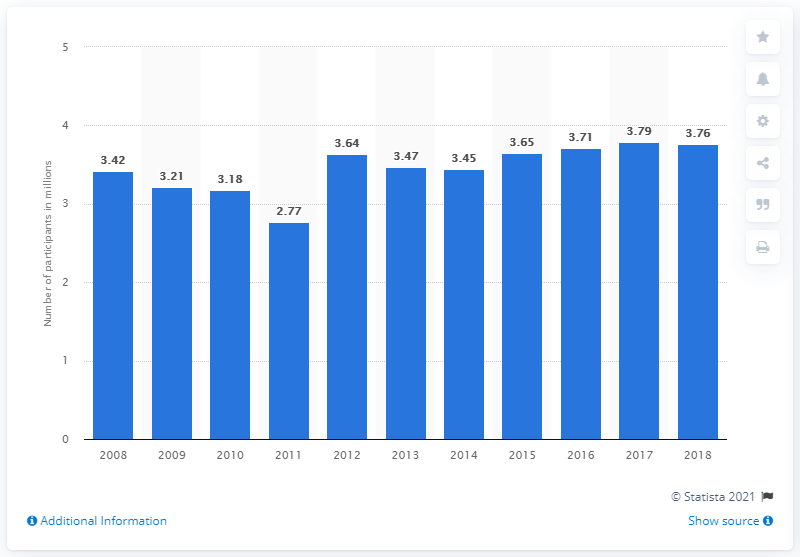Identify some key points in this picture. There were 3,760 participants in Tai Chi in 2018. 